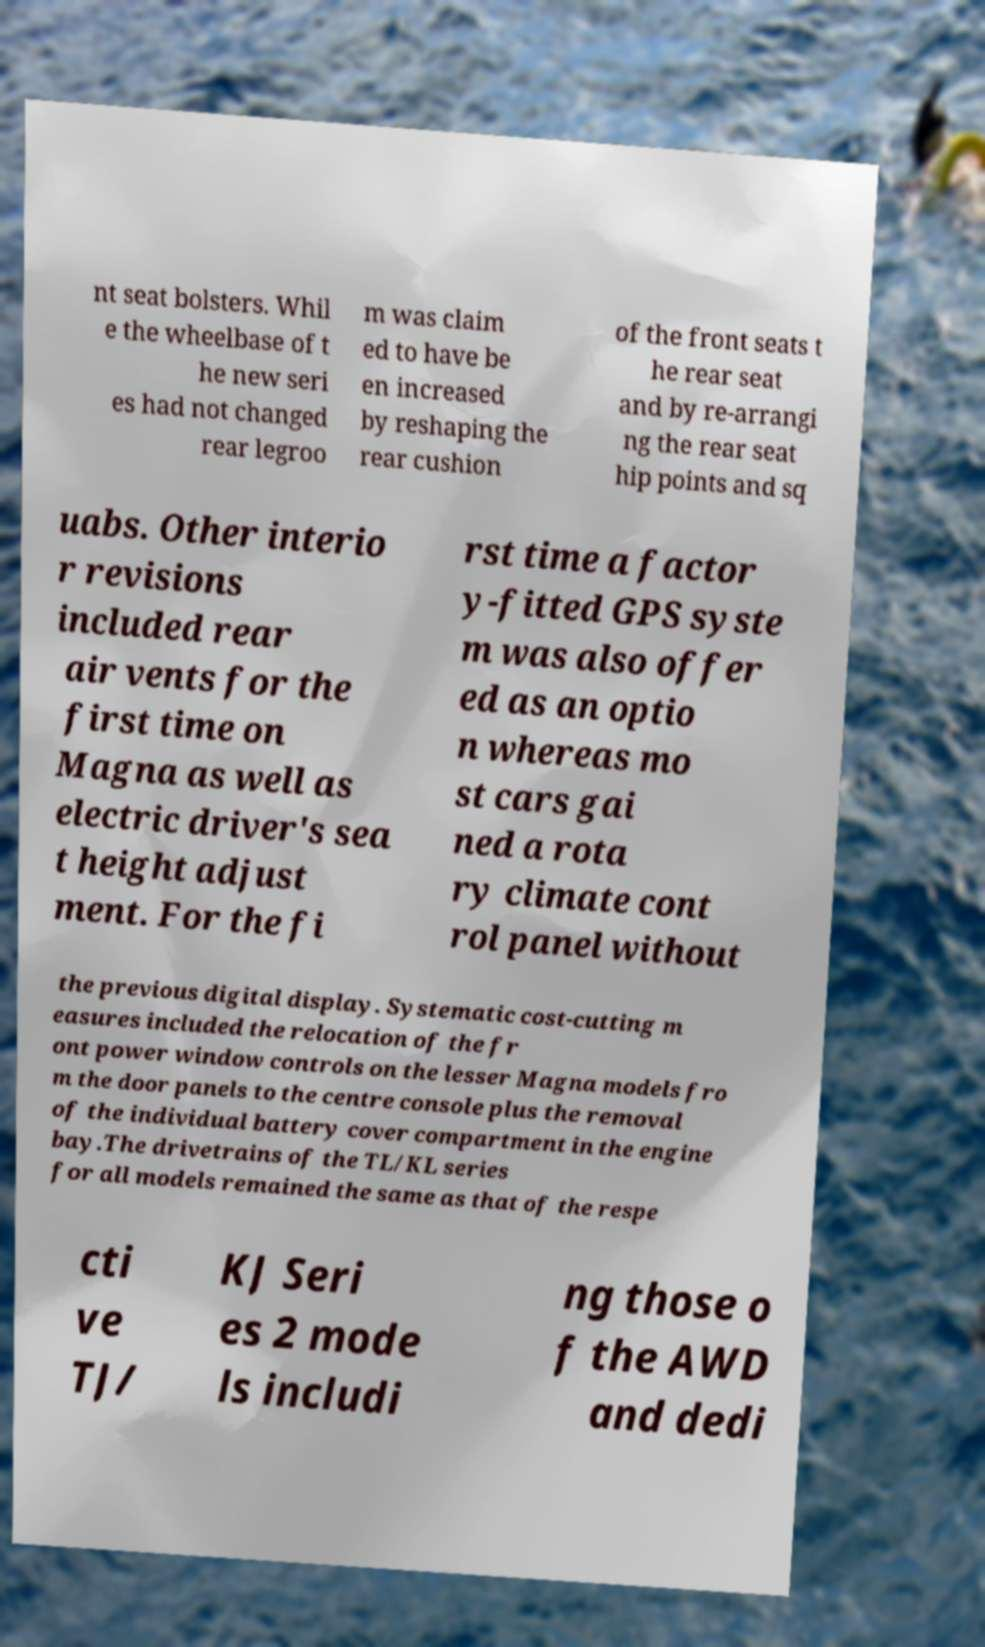I need the written content from this picture converted into text. Can you do that? nt seat bolsters. Whil e the wheelbase of t he new seri es had not changed rear legroo m was claim ed to have be en increased by reshaping the rear cushion of the front seats t he rear seat and by re-arrangi ng the rear seat hip points and sq uabs. Other interio r revisions included rear air vents for the first time on Magna as well as electric driver's sea t height adjust ment. For the fi rst time a factor y-fitted GPS syste m was also offer ed as an optio n whereas mo st cars gai ned a rota ry climate cont rol panel without the previous digital display. Systematic cost-cutting m easures included the relocation of the fr ont power window controls on the lesser Magna models fro m the door panels to the centre console plus the removal of the individual battery cover compartment in the engine bay.The drivetrains of the TL/KL series for all models remained the same as that of the respe cti ve TJ/ KJ Seri es 2 mode ls includi ng those o f the AWD and dedi 